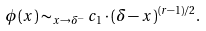<formula> <loc_0><loc_0><loc_500><loc_500>\phi ( x ) \sim _ { x \to \delta ^ { - } } c _ { 1 } \cdot ( \delta - x ) ^ { ( r - 1 ) / 2 } .</formula> 